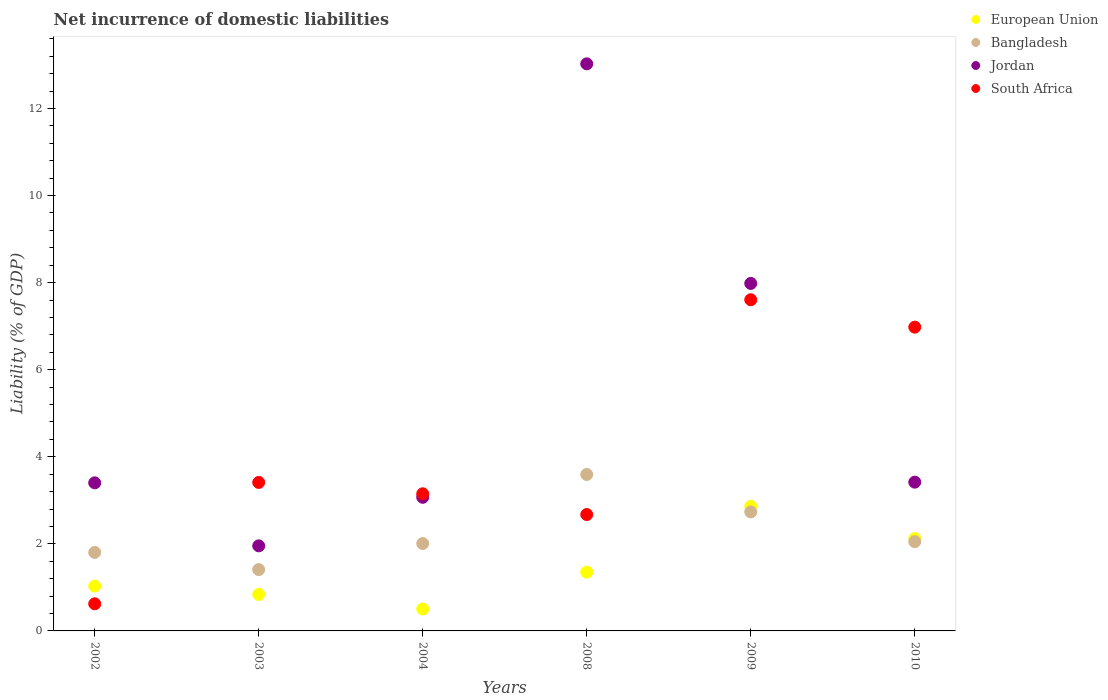How many different coloured dotlines are there?
Provide a succinct answer. 4. Is the number of dotlines equal to the number of legend labels?
Your response must be concise. Yes. What is the net incurrence of domestic liabilities in European Union in 2008?
Your answer should be very brief. 1.35. Across all years, what is the maximum net incurrence of domestic liabilities in European Union?
Your answer should be very brief. 2.86. Across all years, what is the minimum net incurrence of domestic liabilities in Jordan?
Keep it short and to the point. 1.95. What is the total net incurrence of domestic liabilities in European Union in the graph?
Provide a succinct answer. 8.7. What is the difference between the net incurrence of domestic liabilities in Bangladesh in 2008 and that in 2009?
Provide a short and direct response. 0.86. What is the difference between the net incurrence of domestic liabilities in Jordan in 2003 and the net incurrence of domestic liabilities in European Union in 2010?
Your response must be concise. -0.17. What is the average net incurrence of domestic liabilities in European Union per year?
Keep it short and to the point. 1.45. In the year 2004, what is the difference between the net incurrence of domestic liabilities in European Union and net incurrence of domestic liabilities in Bangladesh?
Provide a succinct answer. -1.5. What is the ratio of the net incurrence of domestic liabilities in Jordan in 2008 to that in 2009?
Provide a short and direct response. 1.63. Is the net incurrence of domestic liabilities in South Africa in 2003 less than that in 2010?
Offer a terse response. Yes. Is the difference between the net incurrence of domestic liabilities in European Union in 2003 and 2004 greater than the difference between the net incurrence of domestic liabilities in Bangladesh in 2003 and 2004?
Give a very brief answer. Yes. What is the difference between the highest and the second highest net incurrence of domestic liabilities in Bangladesh?
Offer a very short reply. 0.86. What is the difference between the highest and the lowest net incurrence of domestic liabilities in South Africa?
Your response must be concise. 6.98. Is the sum of the net incurrence of domestic liabilities in European Union in 2004 and 2009 greater than the maximum net incurrence of domestic liabilities in South Africa across all years?
Ensure brevity in your answer.  No. Is it the case that in every year, the sum of the net incurrence of domestic liabilities in Bangladesh and net incurrence of domestic liabilities in Jordan  is greater than the net incurrence of domestic liabilities in South Africa?
Provide a short and direct response. No. Does the net incurrence of domestic liabilities in Bangladesh monotonically increase over the years?
Make the answer very short. No. How many years are there in the graph?
Make the answer very short. 6. What is the difference between two consecutive major ticks on the Y-axis?
Give a very brief answer. 2. Are the values on the major ticks of Y-axis written in scientific E-notation?
Offer a very short reply. No. Where does the legend appear in the graph?
Your response must be concise. Top right. How many legend labels are there?
Your answer should be compact. 4. What is the title of the graph?
Make the answer very short. Net incurrence of domestic liabilities. What is the label or title of the X-axis?
Give a very brief answer. Years. What is the label or title of the Y-axis?
Keep it short and to the point. Liability (% of GDP). What is the Liability (% of GDP) in European Union in 2002?
Ensure brevity in your answer.  1.03. What is the Liability (% of GDP) of Bangladesh in 2002?
Keep it short and to the point. 1.8. What is the Liability (% of GDP) of Jordan in 2002?
Make the answer very short. 3.4. What is the Liability (% of GDP) in South Africa in 2002?
Offer a very short reply. 0.62. What is the Liability (% of GDP) in European Union in 2003?
Provide a succinct answer. 0.84. What is the Liability (% of GDP) in Bangladesh in 2003?
Keep it short and to the point. 1.41. What is the Liability (% of GDP) of Jordan in 2003?
Offer a very short reply. 1.95. What is the Liability (% of GDP) of South Africa in 2003?
Keep it short and to the point. 3.41. What is the Liability (% of GDP) in European Union in 2004?
Your answer should be very brief. 0.5. What is the Liability (% of GDP) in Bangladesh in 2004?
Offer a very short reply. 2.01. What is the Liability (% of GDP) in Jordan in 2004?
Your response must be concise. 3.07. What is the Liability (% of GDP) in South Africa in 2004?
Offer a terse response. 3.15. What is the Liability (% of GDP) of European Union in 2008?
Your answer should be very brief. 1.35. What is the Liability (% of GDP) of Bangladesh in 2008?
Provide a succinct answer. 3.59. What is the Liability (% of GDP) of Jordan in 2008?
Make the answer very short. 13.02. What is the Liability (% of GDP) in South Africa in 2008?
Offer a very short reply. 2.67. What is the Liability (% of GDP) of European Union in 2009?
Offer a very short reply. 2.86. What is the Liability (% of GDP) in Bangladesh in 2009?
Make the answer very short. 2.73. What is the Liability (% of GDP) in Jordan in 2009?
Offer a terse response. 7.98. What is the Liability (% of GDP) of South Africa in 2009?
Give a very brief answer. 7.61. What is the Liability (% of GDP) of European Union in 2010?
Make the answer very short. 2.12. What is the Liability (% of GDP) in Bangladesh in 2010?
Make the answer very short. 2.05. What is the Liability (% of GDP) in Jordan in 2010?
Provide a succinct answer. 3.42. What is the Liability (% of GDP) of South Africa in 2010?
Your answer should be compact. 6.98. Across all years, what is the maximum Liability (% of GDP) in European Union?
Make the answer very short. 2.86. Across all years, what is the maximum Liability (% of GDP) of Bangladesh?
Keep it short and to the point. 3.59. Across all years, what is the maximum Liability (% of GDP) in Jordan?
Keep it short and to the point. 13.02. Across all years, what is the maximum Liability (% of GDP) in South Africa?
Make the answer very short. 7.61. Across all years, what is the minimum Liability (% of GDP) of European Union?
Your response must be concise. 0.5. Across all years, what is the minimum Liability (% of GDP) of Bangladesh?
Keep it short and to the point. 1.41. Across all years, what is the minimum Liability (% of GDP) of Jordan?
Your answer should be very brief. 1.95. Across all years, what is the minimum Liability (% of GDP) in South Africa?
Offer a terse response. 0.62. What is the total Liability (% of GDP) in European Union in the graph?
Your response must be concise. 8.7. What is the total Liability (% of GDP) of Bangladesh in the graph?
Keep it short and to the point. 13.59. What is the total Liability (% of GDP) of Jordan in the graph?
Your response must be concise. 32.84. What is the total Liability (% of GDP) of South Africa in the graph?
Your answer should be compact. 24.44. What is the difference between the Liability (% of GDP) in European Union in 2002 and that in 2003?
Keep it short and to the point. 0.19. What is the difference between the Liability (% of GDP) of Bangladesh in 2002 and that in 2003?
Ensure brevity in your answer.  0.39. What is the difference between the Liability (% of GDP) of Jordan in 2002 and that in 2003?
Your answer should be very brief. 1.45. What is the difference between the Liability (% of GDP) in South Africa in 2002 and that in 2003?
Offer a very short reply. -2.79. What is the difference between the Liability (% of GDP) in European Union in 2002 and that in 2004?
Provide a succinct answer. 0.53. What is the difference between the Liability (% of GDP) of Bangladesh in 2002 and that in 2004?
Your answer should be very brief. -0.2. What is the difference between the Liability (% of GDP) in Jordan in 2002 and that in 2004?
Provide a succinct answer. 0.33. What is the difference between the Liability (% of GDP) in South Africa in 2002 and that in 2004?
Keep it short and to the point. -2.53. What is the difference between the Liability (% of GDP) of European Union in 2002 and that in 2008?
Offer a very short reply. -0.32. What is the difference between the Liability (% of GDP) in Bangladesh in 2002 and that in 2008?
Give a very brief answer. -1.79. What is the difference between the Liability (% of GDP) in Jordan in 2002 and that in 2008?
Provide a short and direct response. -9.62. What is the difference between the Liability (% of GDP) of South Africa in 2002 and that in 2008?
Your answer should be very brief. -2.05. What is the difference between the Liability (% of GDP) of European Union in 2002 and that in 2009?
Provide a short and direct response. -1.83. What is the difference between the Liability (% of GDP) in Bangladesh in 2002 and that in 2009?
Ensure brevity in your answer.  -0.93. What is the difference between the Liability (% of GDP) of Jordan in 2002 and that in 2009?
Offer a terse response. -4.58. What is the difference between the Liability (% of GDP) of South Africa in 2002 and that in 2009?
Offer a very short reply. -6.98. What is the difference between the Liability (% of GDP) of European Union in 2002 and that in 2010?
Your answer should be very brief. -1.09. What is the difference between the Liability (% of GDP) in Bangladesh in 2002 and that in 2010?
Your answer should be compact. -0.25. What is the difference between the Liability (% of GDP) of Jordan in 2002 and that in 2010?
Provide a succinct answer. -0.02. What is the difference between the Liability (% of GDP) of South Africa in 2002 and that in 2010?
Offer a very short reply. -6.35. What is the difference between the Liability (% of GDP) of European Union in 2003 and that in 2004?
Provide a short and direct response. 0.34. What is the difference between the Liability (% of GDP) of Bangladesh in 2003 and that in 2004?
Your answer should be compact. -0.6. What is the difference between the Liability (% of GDP) in Jordan in 2003 and that in 2004?
Provide a succinct answer. -1.11. What is the difference between the Liability (% of GDP) of South Africa in 2003 and that in 2004?
Your answer should be very brief. 0.26. What is the difference between the Liability (% of GDP) of European Union in 2003 and that in 2008?
Offer a very short reply. -0.51. What is the difference between the Liability (% of GDP) in Bangladesh in 2003 and that in 2008?
Ensure brevity in your answer.  -2.18. What is the difference between the Liability (% of GDP) of Jordan in 2003 and that in 2008?
Make the answer very short. -11.07. What is the difference between the Liability (% of GDP) in South Africa in 2003 and that in 2008?
Your response must be concise. 0.74. What is the difference between the Liability (% of GDP) of European Union in 2003 and that in 2009?
Your answer should be compact. -2.02. What is the difference between the Liability (% of GDP) in Bangladesh in 2003 and that in 2009?
Offer a terse response. -1.32. What is the difference between the Liability (% of GDP) of Jordan in 2003 and that in 2009?
Make the answer very short. -6.03. What is the difference between the Liability (% of GDP) in South Africa in 2003 and that in 2009?
Make the answer very short. -4.2. What is the difference between the Liability (% of GDP) in European Union in 2003 and that in 2010?
Provide a short and direct response. -1.28. What is the difference between the Liability (% of GDP) in Bangladesh in 2003 and that in 2010?
Offer a very short reply. -0.64. What is the difference between the Liability (% of GDP) in Jordan in 2003 and that in 2010?
Give a very brief answer. -1.46. What is the difference between the Liability (% of GDP) in South Africa in 2003 and that in 2010?
Provide a succinct answer. -3.57. What is the difference between the Liability (% of GDP) of European Union in 2004 and that in 2008?
Your answer should be compact. -0.85. What is the difference between the Liability (% of GDP) of Bangladesh in 2004 and that in 2008?
Offer a very short reply. -1.59. What is the difference between the Liability (% of GDP) of Jordan in 2004 and that in 2008?
Offer a terse response. -9.96. What is the difference between the Liability (% of GDP) of South Africa in 2004 and that in 2008?
Offer a very short reply. 0.48. What is the difference between the Liability (% of GDP) in European Union in 2004 and that in 2009?
Make the answer very short. -2.36. What is the difference between the Liability (% of GDP) in Bangladesh in 2004 and that in 2009?
Keep it short and to the point. -0.73. What is the difference between the Liability (% of GDP) of Jordan in 2004 and that in 2009?
Provide a short and direct response. -4.91. What is the difference between the Liability (% of GDP) in South Africa in 2004 and that in 2009?
Make the answer very short. -4.46. What is the difference between the Liability (% of GDP) of European Union in 2004 and that in 2010?
Offer a very short reply. -1.62. What is the difference between the Liability (% of GDP) of Bangladesh in 2004 and that in 2010?
Offer a terse response. -0.04. What is the difference between the Liability (% of GDP) in Jordan in 2004 and that in 2010?
Keep it short and to the point. -0.35. What is the difference between the Liability (% of GDP) in South Africa in 2004 and that in 2010?
Provide a short and direct response. -3.83. What is the difference between the Liability (% of GDP) of European Union in 2008 and that in 2009?
Offer a terse response. -1.51. What is the difference between the Liability (% of GDP) of Bangladesh in 2008 and that in 2009?
Give a very brief answer. 0.86. What is the difference between the Liability (% of GDP) in Jordan in 2008 and that in 2009?
Provide a succinct answer. 5.04. What is the difference between the Liability (% of GDP) of South Africa in 2008 and that in 2009?
Your answer should be compact. -4.93. What is the difference between the Liability (% of GDP) of European Union in 2008 and that in 2010?
Give a very brief answer. -0.77. What is the difference between the Liability (% of GDP) of Bangladesh in 2008 and that in 2010?
Give a very brief answer. 1.54. What is the difference between the Liability (% of GDP) of Jordan in 2008 and that in 2010?
Provide a succinct answer. 9.61. What is the difference between the Liability (% of GDP) in South Africa in 2008 and that in 2010?
Provide a succinct answer. -4.3. What is the difference between the Liability (% of GDP) in European Union in 2009 and that in 2010?
Offer a very short reply. 0.74. What is the difference between the Liability (% of GDP) in Bangladesh in 2009 and that in 2010?
Offer a very short reply. 0.68. What is the difference between the Liability (% of GDP) of Jordan in 2009 and that in 2010?
Offer a very short reply. 4.56. What is the difference between the Liability (% of GDP) of South Africa in 2009 and that in 2010?
Your response must be concise. 0.63. What is the difference between the Liability (% of GDP) in European Union in 2002 and the Liability (% of GDP) in Bangladesh in 2003?
Provide a short and direct response. -0.38. What is the difference between the Liability (% of GDP) in European Union in 2002 and the Liability (% of GDP) in Jordan in 2003?
Your answer should be compact. -0.92. What is the difference between the Liability (% of GDP) of European Union in 2002 and the Liability (% of GDP) of South Africa in 2003?
Make the answer very short. -2.38. What is the difference between the Liability (% of GDP) of Bangladesh in 2002 and the Liability (% of GDP) of Jordan in 2003?
Offer a terse response. -0.15. What is the difference between the Liability (% of GDP) in Bangladesh in 2002 and the Liability (% of GDP) in South Africa in 2003?
Your answer should be very brief. -1.61. What is the difference between the Liability (% of GDP) of Jordan in 2002 and the Liability (% of GDP) of South Africa in 2003?
Offer a very short reply. -0.01. What is the difference between the Liability (% of GDP) of European Union in 2002 and the Liability (% of GDP) of Bangladesh in 2004?
Give a very brief answer. -0.98. What is the difference between the Liability (% of GDP) in European Union in 2002 and the Liability (% of GDP) in Jordan in 2004?
Offer a terse response. -2.04. What is the difference between the Liability (% of GDP) of European Union in 2002 and the Liability (% of GDP) of South Africa in 2004?
Provide a succinct answer. -2.12. What is the difference between the Liability (% of GDP) of Bangladesh in 2002 and the Liability (% of GDP) of Jordan in 2004?
Give a very brief answer. -1.27. What is the difference between the Liability (% of GDP) in Bangladesh in 2002 and the Liability (% of GDP) in South Africa in 2004?
Provide a succinct answer. -1.35. What is the difference between the Liability (% of GDP) in Jordan in 2002 and the Liability (% of GDP) in South Africa in 2004?
Keep it short and to the point. 0.25. What is the difference between the Liability (% of GDP) in European Union in 2002 and the Liability (% of GDP) in Bangladesh in 2008?
Offer a very short reply. -2.56. What is the difference between the Liability (% of GDP) in European Union in 2002 and the Liability (% of GDP) in Jordan in 2008?
Your response must be concise. -11.99. What is the difference between the Liability (% of GDP) in European Union in 2002 and the Liability (% of GDP) in South Africa in 2008?
Ensure brevity in your answer.  -1.64. What is the difference between the Liability (% of GDP) in Bangladesh in 2002 and the Liability (% of GDP) in Jordan in 2008?
Make the answer very short. -11.22. What is the difference between the Liability (% of GDP) in Bangladesh in 2002 and the Liability (% of GDP) in South Africa in 2008?
Provide a short and direct response. -0.87. What is the difference between the Liability (% of GDP) in Jordan in 2002 and the Liability (% of GDP) in South Africa in 2008?
Offer a very short reply. 0.73. What is the difference between the Liability (% of GDP) of European Union in 2002 and the Liability (% of GDP) of Bangladesh in 2009?
Ensure brevity in your answer.  -1.7. What is the difference between the Liability (% of GDP) of European Union in 2002 and the Liability (% of GDP) of Jordan in 2009?
Give a very brief answer. -6.95. What is the difference between the Liability (% of GDP) in European Union in 2002 and the Liability (% of GDP) in South Africa in 2009?
Make the answer very short. -6.58. What is the difference between the Liability (% of GDP) in Bangladesh in 2002 and the Liability (% of GDP) in Jordan in 2009?
Keep it short and to the point. -6.18. What is the difference between the Liability (% of GDP) of Bangladesh in 2002 and the Liability (% of GDP) of South Africa in 2009?
Offer a very short reply. -5.8. What is the difference between the Liability (% of GDP) of Jordan in 2002 and the Liability (% of GDP) of South Africa in 2009?
Give a very brief answer. -4.2. What is the difference between the Liability (% of GDP) of European Union in 2002 and the Liability (% of GDP) of Bangladesh in 2010?
Ensure brevity in your answer.  -1.02. What is the difference between the Liability (% of GDP) in European Union in 2002 and the Liability (% of GDP) in Jordan in 2010?
Keep it short and to the point. -2.39. What is the difference between the Liability (% of GDP) of European Union in 2002 and the Liability (% of GDP) of South Africa in 2010?
Your answer should be compact. -5.95. What is the difference between the Liability (% of GDP) of Bangladesh in 2002 and the Liability (% of GDP) of Jordan in 2010?
Ensure brevity in your answer.  -1.61. What is the difference between the Liability (% of GDP) of Bangladesh in 2002 and the Liability (% of GDP) of South Africa in 2010?
Ensure brevity in your answer.  -5.17. What is the difference between the Liability (% of GDP) in Jordan in 2002 and the Liability (% of GDP) in South Africa in 2010?
Make the answer very short. -3.58. What is the difference between the Liability (% of GDP) in European Union in 2003 and the Liability (% of GDP) in Bangladesh in 2004?
Your answer should be compact. -1.17. What is the difference between the Liability (% of GDP) of European Union in 2003 and the Liability (% of GDP) of Jordan in 2004?
Provide a short and direct response. -2.23. What is the difference between the Liability (% of GDP) of European Union in 2003 and the Liability (% of GDP) of South Africa in 2004?
Keep it short and to the point. -2.31. What is the difference between the Liability (% of GDP) of Bangladesh in 2003 and the Liability (% of GDP) of Jordan in 2004?
Provide a succinct answer. -1.66. What is the difference between the Liability (% of GDP) in Bangladesh in 2003 and the Liability (% of GDP) in South Africa in 2004?
Provide a succinct answer. -1.74. What is the difference between the Liability (% of GDP) of Jordan in 2003 and the Liability (% of GDP) of South Africa in 2004?
Offer a terse response. -1.2. What is the difference between the Liability (% of GDP) in European Union in 2003 and the Liability (% of GDP) in Bangladesh in 2008?
Your answer should be compact. -2.75. What is the difference between the Liability (% of GDP) of European Union in 2003 and the Liability (% of GDP) of Jordan in 2008?
Your answer should be very brief. -12.19. What is the difference between the Liability (% of GDP) of European Union in 2003 and the Liability (% of GDP) of South Africa in 2008?
Provide a short and direct response. -1.83. What is the difference between the Liability (% of GDP) of Bangladesh in 2003 and the Liability (% of GDP) of Jordan in 2008?
Your response must be concise. -11.62. What is the difference between the Liability (% of GDP) in Bangladesh in 2003 and the Liability (% of GDP) in South Africa in 2008?
Ensure brevity in your answer.  -1.26. What is the difference between the Liability (% of GDP) in Jordan in 2003 and the Liability (% of GDP) in South Africa in 2008?
Ensure brevity in your answer.  -0.72. What is the difference between the Liability (% of GDP) in European Union in 2003 and the Liability (% of GDP) in Bangladesh in 2009?
Offer a terse response. -1.89. What is the difference between the Liability (% of GDP) in European Union in 2003 and the Liability (% of GDP) in Jordan in 2009?
Your response must be concise. -7.14. What is the difference between the Liability (% of GDP) of European Union in 2003 and the Liability (% of GDP) of South Africa in 2009?
Your response must be concise. -6.77. What is the difference between the Liability (% of GDP) in Bangladesh in 2003 and the Liability (% of GDP) in Jordan in 2009?
Your response must be concise. -6.57. What is the difference between the Liability (% of GDP) of Bangladesh in 2003 and the Liability (% of GDP) of South Africa in 2009?
Offer a terse response. -6.2. What is the difference between the Liability (% of GDP) in Jordan in 2003 and the Liability (% of GDP) in South Africa in 2009?
Your response must be concise. -5.65. What is the difference between the Liability (% of GDP) in European Union in 2003 and the Liability (% of GDP) in Bangladesh in 2010?
Provide a succinct answer. -1.21. What is the difference between the Liability (% of GDP) in European Union in 2003 and the Liability (% of GDP) in Jordan in 2010?
Keep it short and to the point. -2.58. What is the difference between the Liability (% of GDP) of European Union in 2003 and the Liability (% of GDP) of South Africa in 2010?
Offer a terse response. -6.14. What is the difference between the Liability (% of GDP) of Bangladesh in 2003 and the Liability (% of GDP) of Jordan in 2010?
Your response must be concise. -2.01. What is the difference between the Liability (% of GDP) of Bangladesh in 2003 and the Liability (% of GDP) of South Africa in 2010?
Give a very brief answer. -5.57. What is the difference between the Liability (% of GDP) of Jordan in 2003 and the Liability (% of GDP) of South Africa in 2010?
Your response must be concise. -5.02. What is the difference between the Liability (% of GDP) in European Union in 2004 and the Liability (% of GDP) in Bangladesh in 2008?
Offer a terse response. -3.09. What is the difference between the Liability (% of GDP) of European Union in 2004 and the Liability (% of GDP) of Jordan in 2008?
Offer a very short reply. -12.52. What is the difference between the Liability (% of GDP) in European Union in 2004 and the Liability (% of GDP) in South Africa in 2008?
Give a very brief answer. -2.17. What is the difference between the Liability (% of GDP) in Bangladesh in 2004 and the Liability (% of GDP) in Jordan in 2008?
Provide a succinct answer. -11.02. What is the difference between the Liability (% of GDP) in Bangladesh in 2004 and the Liability (% of GDP) in South Africa in 2008?
Offer a terse response. -0.67. What is the difference between the Liability (% of GDP) in Jordan in 2004 and the Liability (% of GDP) in South Africa in 2008?
Give a very brief answer. 0.4. What is the difference between the Liability (% of GDP) in European Union in 2004 and the Liability (% of GDP) in Bangladesh in 2009?
Make the answer very short. -2.23. What is the difference between the Liability (% of GDP) of European Union in 2004 and the Liability (% of GDP) of Jordan in 2009?
Provide a succinct answer. -7.48. What is the difference between the Liability (% of GDP) in European Union in 2004 and the Liability (% of GDP) in South Africa in 2009?
Make the answer very short. -7.1. What is the difference between the Liability (% of GDP) of Bangladesh in 2004 and the Liability (% of GDP) of Jordan in 2009?
Offer a very short reply. -5.97. What is the difference between the Liability (% of GDP) in Bangladesh in 2004 and the Liability (% of GDP) in South Africa in 2009?
Your answer should be compact. -5.6. What is the difference between the Liability (% of GDP) of Jordan in 2004 and the Liability (% of GDP) of South Africa in 2009?
Your response must be concise. -4.54. What is the difference between the Liability (% of GDP) of European Union in 2004 and the Liability (% of GDP) of Bangladesh in 2010?
Keep it short and to the point. -1.55. What is the difference between the Liability (% of GDP) in European Union in 2004 and the Liability (% of GDP) in Jordan in 2010?
Your answer should be very brief. -2.91. What is the difference between the Liability (% of GDP) in European Union in 2004 and the Liability (% of GDP) in South Africa in 2010?
Offer a terse response. -6.47. What is the difference between the Liability (% of GDP) of Bangladesh in 2004 and the Liability (% of GDP) of Jordan in 2010?
Offer a terse response. -1.41. What is the difference between the Liability (% of GDP) in Bangladesh in 2004 and the Liability (% of GDP) in South Africa in 2010?
Your response must be concise. -4.97. What is the difference between the Liability (% of GDP) of Jordan in 2004 and the Liability (% of GDP) of South Africa in 2010?
Provide a succinct answer. -3.91. What is the difference between the Liability (% of GDP) of European Union in 2008 and the Liability (% of GDP) of Bangladesh in 2009?
Offer a terse response. -1.38. What is the difference between the Liability (% of GDP) in European Union in 2008 and the Liability (% of GDP) in Jordan in 2009?
Your answer should be compact. -6.63. What is the difference between the Liability (% of GDP) in European Union in 2008 and the Liability (% of GDP) in South Africa in 2009?
Your response must be concise. -6.26. What is the difference between the Liability (% of GDP) in Bangladesh in 2008 and the Liability (% of GDP) in Jordan in 2009?
Your answer should be very brief. -4.39. What is the difference between the Liability (% of GDP) of Bangladesh in 2008 and the Liability (% of GDP) of South Africa in 2009?
Provide a succinct answer. -4.01. What is the difference between the Liability (% of GDP) in Jordan in 2008 and the Liability (% of GDP) in South Africa in 2009?
Offer a terse response. 5.42. What is the difference between the Liability (% of GDP) in European Union in 2008 and the Liability (% of GDP) in Bangladesh in 2010?
Your answer should be compact. -0.7. What is the difference between the Liability (% of GDP) in European Union in 2008 and the Liability (% of GDP) in Jordan in 2010?
Offer a terse response. -2.07. What is the difference between the Liability (% of GDP) of European Union in 2008 and the Liability (% of GDP) of South Africa in 2010?
Ensure brevity in your answer.  -5.63. What is the difference between the Liability (% of GDP) of Bangladesh in 2008 and the Liability (% of GDP) of Jordan in 2010?
Provide a succinct answer. 0.18. What is the difference between the Liability (% of GDP) of Bangladesh in 2008 and the Liability (% of GDP) of South Africa in 2010?
Make the answer very short. -3.38. What is the difference between the Liability (% of GDP) in Jordan in 2008 and the Liability (% of GDP) in South Africa in 2010?
Your response must be concise. 6.05. What is the difference between the Liability (% of GDP) of European Union in 2009 and the Liability (% of GDP) of Bangladesh in 2010?
Your answer should be very brief. 0.81. What is the difference between the Liability (% of GDP) in European Union in 2009 and the Liability (% of GDP) in Jordan in 2010?
Your answer should be very brief. -0.56. What is the difference between the Liability (% of GDP) of European Union in 2009 and the Liability (% of GDP) of South Africa in 2010?
Ensure brevity in your answer.  -4.12. What is the difference between the Liability (% of GDP) of Bangladesh in 2009 and the Liability (% of GDP) of Jordan in 2010?
Your response must be concise. -0.68. What is the difference between the Liability (% of GDP) in Bangladesh in 2009 and the Liability (% of GDP) in South Africa in 2010?
Your answer should be compact. -4.24. What is the average Liability (% of GDP) of European Union per year?
Ensure brevity in your answer.  1.45. What is the average Liability (% of GDP) of Bangladesh per year?
Ensure brevity in your answer.  2.27. What is the average Liability (% of GDP) in Jordan per year?
Make the answer very short. 5.47. What is the average Liability (% of GDP) of South Africa per year?
Give a very brief answer. 4.07. In the year 2002, what is the difference between the Liability (% of GDP) of European Union and Liability (% of GDP) of Bangladesh?
Give a very brief answer. -0.77. In the year 2002, what is the difference between the Liability (% of GDP) of European Union and Liability (% of GDP) of Jordan?
Keep it short and to the point. -2.37. In the year 2002, what is the difference between the Liability (% of GDP) in European Union and Liability (% of GDP) in South Africa?
Your answer should be compact. 0.41. In the year 2002, what is the difference between the Liability (% of GDP) in Bangladesh and Liability (% of GDP) in Jordan?
Offer a very short reply. -1.6. In the year 2002, what is the difference between the Liability (% of GDP) in Bangladesh and Liability (% of GDP) in South Africa?
Provide a short and direct response. 1.18. In the year 2002, what is the difference between the Liability (% of GDP) of Jordan and Liability (% of GDP) of South Africa?
Your answer should be very brief. 2.78. In the year 2003, what is the difference between the Liability (% of GDP) of European Union and Liability (% of GDP) of Bangladesh?
Offer a terse response. -0.57. In the year 2003, what is the difference between the Liability (% of GDP) in European Union and Liability (% of GDP) in Jordan?
Give a very brief answer. -1.12. In the year 2003, what is the difference between the Liability (% of GDP) of European Union and Liability (% of GDP) of South Africa?
Offer a terse response. -2.57. In the year 2003, what is the difference between the Liability (% of GDP) in Bangladesh and Liability (% of GDP) in Jordan?
Make the answer very short. -0.55. In the year 2003, what is the difference between the Liability (% of GDP) of Bangladesh and Liability (% of GDP) of South Africa?
Your response must be concise. -2. In the year 2003, what is the difference between the Liability (% of GDP) in Jordan and Liability (% of GDP) in South Africa?
Your answer should be very brief. -1.46. In the year 2004, what is the difference between the Liability (% of GDP) of European Union and Liability (% of GDP) of Bangladesh?
Provide a succinct answer. -1.5. In the year 2004, what is the difference between the Liability (% of GDP) of European Union and Liability (% of GDP) of Jordan?
Give a very brief answer. -2.57. In the year 2004, what is the difference between the Liability (% of GDP) in European Union and Liability (% of GDP) in South Africa?
Keep it short and to the point. -2.65. In the year 2004, what is the difference between the Liability (% of GDP) of Bangladesh and Liability (% of GDP) of Jordan?
Provide a succinct answer. -1.06. In the year 2004, what is the difference between the Liability (% of GDP) of Bangladesh and Liability (% of GDP) of South Africa?
Your answer should be very brief. -1.14. In the year 2004, what is the difference between the Liability (% of GDP) of Jordan and Liability (% of GDP) of South Africa?
Offer a very short reply. -0.08. In the year 2008, what is the difference between the Liability (% of GDP) in European Union and Liability (% of GDP) in Bangladesh?
Your answer should be compact. -2.24. In the year 2008, what is the difference between the Liability (% of GDP) of European Union and Liability (% of GDP) of Jordan?
Provide a succinct answer. -11.67. In the year 2008, what is the difference between the Liability (% of GDP) of European Union and Liability (% of GDP) of South Africa?
Offer a very short reply. -1.32. In the year 2008, what is the difference between the Liability (% of GDP) in Bangladesh and Liability (% of GDP) in Jordan?
Offer a very short reply. -9.43. In the year 2008, what is the difference between the Liability (% of GDP) in Bangladesh and Liability (% of GDP) in South Africa?
Your response must be concise. 0.92. In the year 2008, what is the difference between the Liability (% of GDP) of Jordan and Liability (% of GDP) of South Africa?
Offer a terse response. 10.35. In the year 2009, what is the difference between the Liability (% of GDP) of European Union and Liability (% of GDP) of Bangladesh?
Your answer should be compact. 0.13. In the year 2009, what is the difference between the Liability (% of GDP) of European Union and Liability (% of GDP) of Jordan?
Keep it short and to the point. -5.12. In the year 2009, what is the difference between the Liability (% of GDP) of European Union and Liability (% of GDP) of South Africa?
Give a very brief answer. -4.75. In the year 2009, what is the difference between the Liability (% of GDP) of Bangladesh and Liability (% of GDP) of Jordan?
Ensure brevity in your answer.  -5.25. In the year 2009, what is the difference between the Liability (% of GDP) in Bangladesh and Liability (% of GDP) in South Africa?
Provide a short and direct response. -4.87. In the year 2009, what is the difference between the Liability (% of GDP) of Jordan and Liability (% of GDP) of South Africa?
Your response must be concise. 0.37. In the year 2010, what is the difference between the Liability (% of GDP) in European Union and Liability (% of GDP) in Bangladesh?
Your response must be concise. 0.07. In the year 2010, what is the difference between the Liability (% of GDP) of European Union and Liability (% of GDP) of Jordan?
Give a very brief answer. -1.3. In the year 2010, what is the difference between the Liability (% of GDP) in European Union and Liability (% of GDP) in South Africa?
Provide a short and direct response. -4.86. In the year 2010, what is the difference between the Liability (% of GDP) in Bangladesh and Liability (% of GDP) in Jordan?
Provide a short and direct response. -1.37. In the year 2010, what is the difference between the Liability (% of GDP) of Bangladesh and Liability (% of GDP) of South Africa?
Offer a terse response. -4.93. In the year 2010, what is the difference between the Liability (% of GDP) of Jordan and Liability (% of GDP) of South Africa?
Offer a terse response. -3.56. What is the ratio of the Liability (% of GDP) of European Union in 2002 to that in 2003?
Your answer should be very brief. 1.23. What is the ratio of the Liability (% of GDP) of Bangladesh in 2002 to that in 2003?
Keep it short and to the point. 1.28. What is the ratio of the Liability (% of GDP) in Jordan in 2002 to that in 2003?
Provide a succinct answer. 1.74. What is the ratio of the Liability (% of GDP) of South Africa in 2002 to that in 2003?
Offer a very short reply. 0.18. What is the ratio of the Liability (% of GDP) of European Union in 2002 to that in 2004?
Offer a very short reply. 2.05. What is the ratio of the Liability (% of GDP) of Bangladesh in 2002 to that in 2004?
Keep it short and to the point. 0.9. What is the ratio of the Liability (% of GDP) in Jordan in 2002 to that in 2004?
Your answer should be very brief. 1.11. What is the ratio of the Liability (% of GDP) of South Africa in 2002 to that in 2004?
Keep it short and to the point. 0.2. What is the ratio of the Liability (% of GDP) of European Union in 2002 to that in 2008?
Offer a terse response. 0.76. What is the ratio of the Liability (% of GDP) in Bangladesh in 2002 to that in 2008?
Your response must be concise. 0.5. What is the ratio of the Liability (% of GDP) in Jordan in 2002 to that in 2008?
Ensure brevity in your answer.  0.26. What is the ratio of the Liability (% of GDP) of South Africa in 2002 to that in 2008?
Your response must be concise. 0.23. What is the ratio of the Liability (% of GDP) of European Union in 2002 to that in 2009?
Your answer should be compact. 0.36. What is the ratio of the Liability (% of GDP) of Bangladesh in 2002 to that in 2009?
Provide a succinct answer. 0.66. What is the ratio of the Liability (% of GDP) of Jordan in 2002 to that in 2009?
Your response must be concise. 0.43. What is the ratio of the Liability (% of GDP) of South Africa in 2002 to that in 2009?
Make the answer very short. 0.08. What is the ratio of the Liability (% of GDP) of European Union in 2002 to that in 2010?
Provide a succinct answer. 0.49. What is the ratio of the Liability (% of GDP) of Bangladesh in 2002 to that in 2010?
Offer a very short reply. 0.88. What is the ratio of the Liability (% of GDP) of Jordan in 2002 to that in 2010?
Keep it short and to the point. 1. What is the ratio of the Liability (% of GDP) of South Africa in 2002 to that in 2010?
Offer a very short reply. 0.09. What is the ratio of the Liability (% of GDP) in European Union in 2003 to that in 2004?
Your response must be concise. 1.67. What is the ratio of the Liability (% of GDP) of Bangladesh in 2003 to that in 2004?
Your response must be concise. 0.7. What is the ratio of the Liability (% of GDP) in Jordan in 2003 to that in 2004?
Provide a short and direct response. 0.64. What is the ratio of the Liability (% of GDP) of South Africa in 2003 to that in 2004?
Provide a succinct answer. 1.08. What is the ratio of the Liability (% of GDP) in European Union in 2003 to that in 2008?
Offer a terse response. 0.62. What is the ratio of the Liability (% of GDP) in Bangladesh in 2003 to that in 2008?
Provide a succinct answer. 0.39. What is the ratio of the Liability (% of GDP) of Jordan in 2003 to that in 2008?
Give a very brief answer. 0.15. What is the ratio of the Liability (% of GDP) of South Africa in 2003 to that in 2008?
Ensure brevity in your answer.  1.28. What is the ratio of the Liability (% of GDP) of European Union in 2003 to that in 2009?
Keep it short and to the point. 0.29. What is the ratio of the Liability (% of GDP) of Bangladesh in 2003 to that in 2009?
Give a very brief answer. 0.52. What is the ratio of the Liability (% of GDP) of Jordan in 2003 to that in 2009?
Offer a very short reply. 0.24. What is the ratio of the Liability (% of GDP) in South Africa in 2003 to that in 2009?
Ensure brevity in your answer.  0.45. What is the ratio of the Liability (% of GDP) of European Union in 2003 to that in 2010?
Provide a succinct answer. 0.4. What is the ratio of the Liability (% of GDP) in Bangladesh in 2003 to that in 2010?
Keep it short and to the point. 0.69. What is the ratio of the Liability (% of GDP) of Jordan in 2003 to that in 2010?
Offer a terse response. 0.57. What is the ratio of the Liability (% of GDP) of South Africa in 2003 to that in 2010?
Offer a very short reply. 0.49. What is the ratio of the Liability (% of GDP) in European Union in 2004 to that in 2008?
Provide a succinct answer. 0.37. What is the ratio of the Liability (% of GDP) in Bangladesh in 2004 to that in 2008?
Your response must be concise. 0.56. What is the ratio of the Liability (% of GDP) in Jordan in 2004 to that in 2008?
Keep it short and to the point. 0.24. What is the ratio of the Liability (% of GDP) of South Africa in 2004 to that in 2008?
Provide a short and direct response. 1.18. What is the ratio of the Liability (% of GDP) in European Union in 2004 to that in 2009?
Make the answer very short. 0.18. What is the ratio of the Liability (% of GDP) in Bangladesh in 2004 to that in 2009?
Your answer should be compact. 0.73. What is the ratio of the Liability (% of GDP) of Jordan in 2004 to that in 2009?
Give a very brief answer. 0.38. What is the ratio of the Liability (% of GDP) of South Africa in 2004 to that in 2009?
Offer a terse response. 0.41. What is the ratio of the Liability (% of GDP) in European Union in 2004 to that in 2010?
Your answer should be very brief. 0.24. What is the ratio of the Liability (% of GDP) in Bangladesh in 2004 to that in 2010?
Provide a succinct answer. 0.98. What is the ratio of the Liability (% of GDP) of Jordan in 2004 to that in 2010?
Give a very brief answer. 0.9. What is the ratio of the Liability (% of GDP) of South Africa in 2004 to that in 2010?
Your answer should be compact. 0.45. What is the ratio of the Liability (% of GDP) of European Union in 2008 to that in 2009?
Offer a terse response. 0.47. What is the ratio of the Liability (% of GDP) in Bangladesh in 2008 to that in 2009?
Give a very brief answer. 1.31. What is the ratio of the Liability (% of GDP) of Jordan in 2008 to that in 2009?
Your answer should be very brief. 1.63. What is the ratio of the Liability (% of GDP) in South Africa in 2008 to that in 2009?
Make the answer very short. 0.35. What is the ratio of the Liability (% of GDP) of European Union in 2008 to that in 2010?
Keep it short and to the point. 0.64. What is the ratio of the Liability (% of GDP) of Bangladesh in 2008 to that in 2010?
Keep it short and to the point. 1.75. What is the ratio of the Liability (% of GDP) of Jordan in 2008 to that in 2010?
Your response must be concise. 3.81. What is the ratio of the Liability (% of GDP) in South Africa in 2008 to that in 2010?
Make the answer very short. 0.38. What is the ratio of the Liability (% of GDP) of European Union in 2009 to that in 2010?
Provide a short and direct response. 1.35. What is the ratio of the Liability (% of GDP) of Bangladesh in 2009 to that in 2010?
Your response must be concise. 1.33. What is the ratio of the Liability (% of GDP) of Jordan in 2009 to that in 2010?
Keep it short and to the point. 2.34. What is the ratio of the Liability (% of GDP) of South Africa in 2009 to that in 2010?
Give a very brief answer. 1.09. What is the difference between the highest and the second highest Liability (% of GDP) in European Union?
Ensure brevity in your answer.  0.74. What is the difference between the highest and the second highest Liability (% of GDP) in Bangladesh?
Offer a very short reply. 0.86. What is the difference between the highest and the second highest Liability (% of GDP) of Jordan?
Make the answer very short. 5.04. What is the difference between the highest and the second highest Liability (% of GDP) in South Africa?
Your answer should be compact. 0.63. What is the difference between the highest and the lowest Liability (% of GDP) in European Union?
Your answer should be compact. 2.36. What is the difference between the highest and the lowest Liability (% of GDP) of Bangladesh?
Keep it short and to the point. 2.18. What is the difference between the highest and the lowest Liability (% of GDP) in Jordan?
Provide a short and direct response. 11.07. What is the difference between the highest and the lowest Liability (% of GDP) in South Africa?
Give a very brief answer. 6.98. 